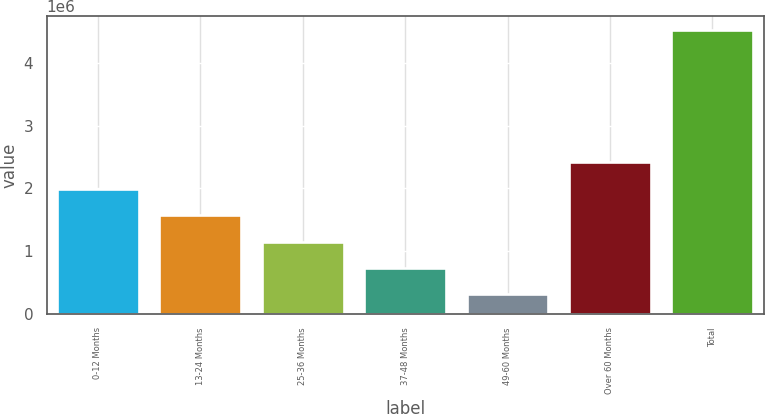Convert chart to OTSL. <chart><loc_0><loc_0><loc_500><loc_500><bar_chart><fcel>0-12 Months<fcel>13-24 Months<fcel>25-36 Months<fcel>37-48 Months<fcel>49-60 Months<fcel>Over 60 Months<fcel>Total<nl><fcel>1.99439e+06<fcel>1.57399e+06<fcel>1.15359e+06<fcel>733190<fcel>312789<fcel>2.4148e+06<fcel>4.5168e+06<nl></chart> 